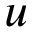<formula> <loc_0><loc_0><loc_500><loc_500>u</formula> 